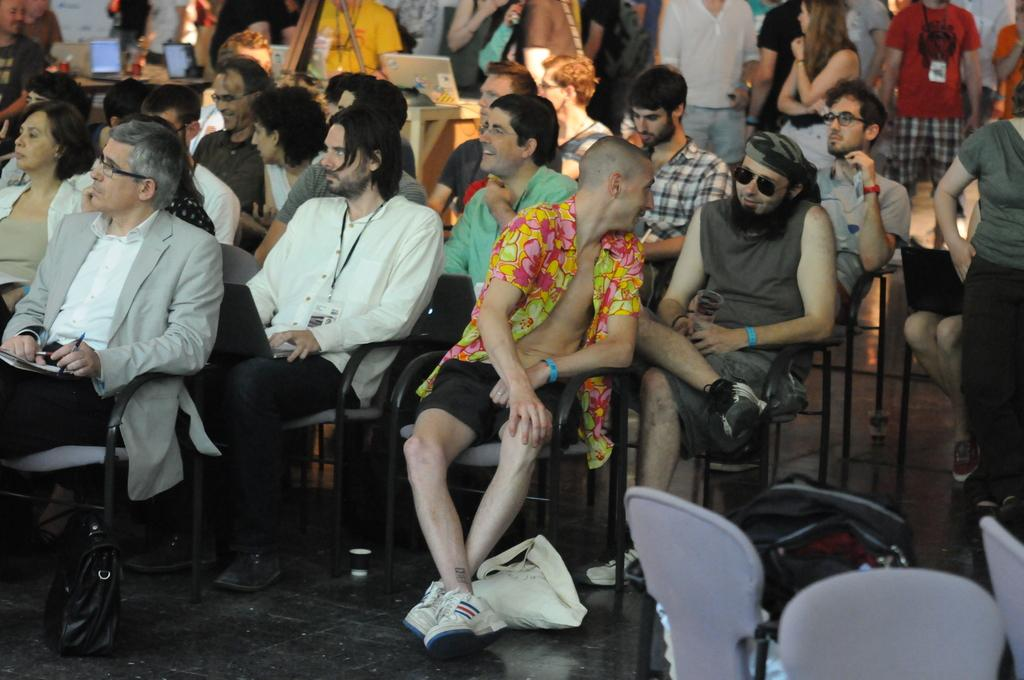What are the persons in the image doing? Some persons are sitting on chairs, while others are standing in the image. What objects can be seen near the persons? There are bags visible in the image. What electronic devices are present in the image? There are laptops present in the image. Can you describe any other items visible in the image? There are other items visible in the image, but their specific nature is not mentioned in the provided facts. Can you tell me how many fans are visible in the image? There is no fan present in the image. What type of match is being played in the image? There is no match being played in the image. 